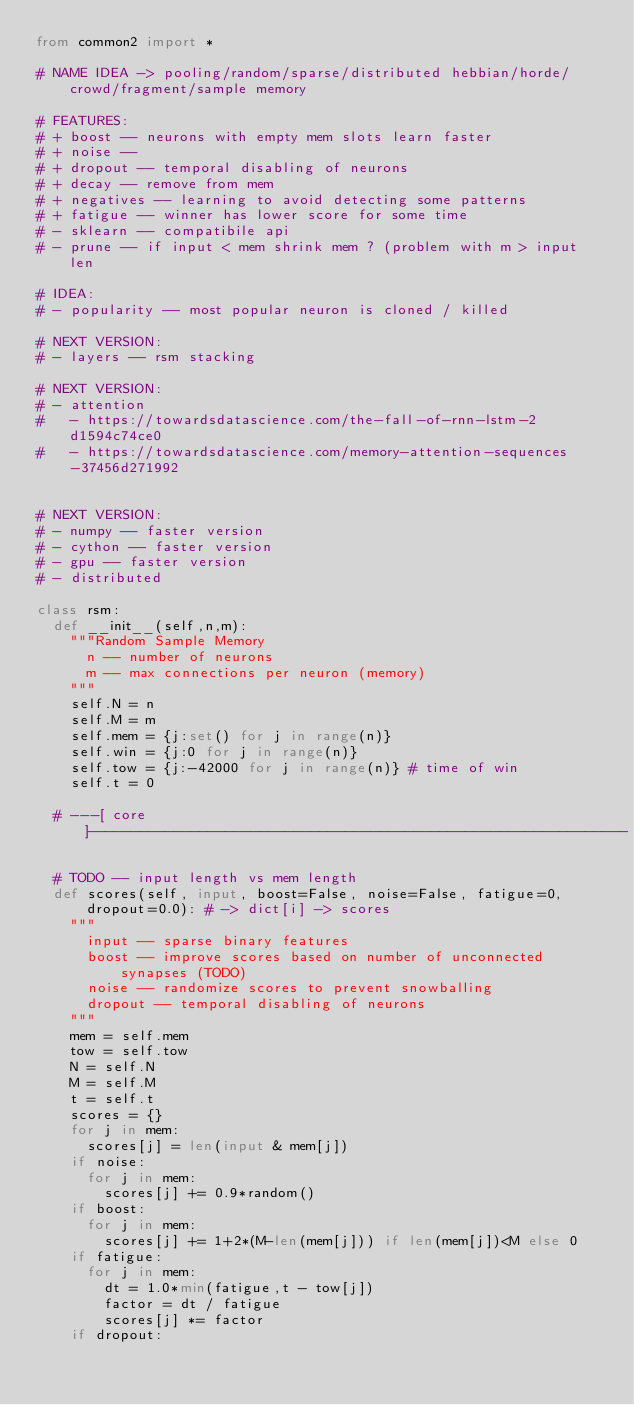<code> <loc_0><loc_0><loc_500><loc_500><_Python_>from common2 import *

# NAME IDEA -> pooling/random/sparse/distributed hebbian/horde/crowd/fragment/sample memory

# FEATURES:
# + boost -- neurons with empty mem slots learn faster
# + noise -- 
# + dropout -- temporal disabling of neurons
# + decay -- remove from mem
# + negatives -- learning to avoid detecting some patterns
# + fatigue -- winner has lower score for some time
# - sklearn -- compatibile api
# - prune -- if input < mem shrink mem ? (problem with m > input len

# IDEA:
# - popularity -- most popular neuron is cloned / killed

# NEXT VERSION:
# - layers -- rsm stacking

# NEXT VERSION:
# - attention
#   - https://towardsdatascience.com/the-fall-of-rnn-lstm-2d1594c74ce0
#   - https://towardsdatascience.com/memory-attention-sequences-37456d271992


# NEXT VERSION:
# - numpy -- faster version
# - cython -- faster version
# - gpu -- faster version
# - distributed 

class rsm:
	def __init__(self,n,m):
		"""Random Sample Memory
			n -- number of neurons
			m -- max connections per neuron (memory)
		"""
		self.N = n
		self.M = m
		self.mem = {j:set() for j in range(n)}
		self.win = {j:0 for j in range(n)}
		self.tow = {j:-42000 for j in range(n)} # time of win
		self.t = 0
	
	# ---[ core ]---------------------------------------------------------------
	
	# TODO -- input length vs mem length
	def scores(self, input, boost=False, noise=False, fatigue=0, dropout=0.0): # -> dict[i] -> scores
		"""
			input -- sparse binary features
			boost -- improve scores based on number of unconnected synapses (TODO)
			noise -- randomize scores to prevent snowballing
			dropout -- temporal disabling of neurons
		"""
		mem = self.mem
		tow = self.tow
		N = self.N
		M = self.M
		t = self.t
		scores = {}
		for j in mem:
			scores[j] = len(input & mem[j])
		if noise:
			for j in mem:
				scores[j] += 0.9*random()
		if boost:
			for j in mem:
				scores[j] += 1+2*(M-len(mem[j])) if len(mem[j])<M else 0
		if fatigue:
			for j in mem:
				dt = 1.0*min(fatigue,t - tow[j])
				factor = dt / fatigue
				scores[j] *= factor
		if dropout:</code> 